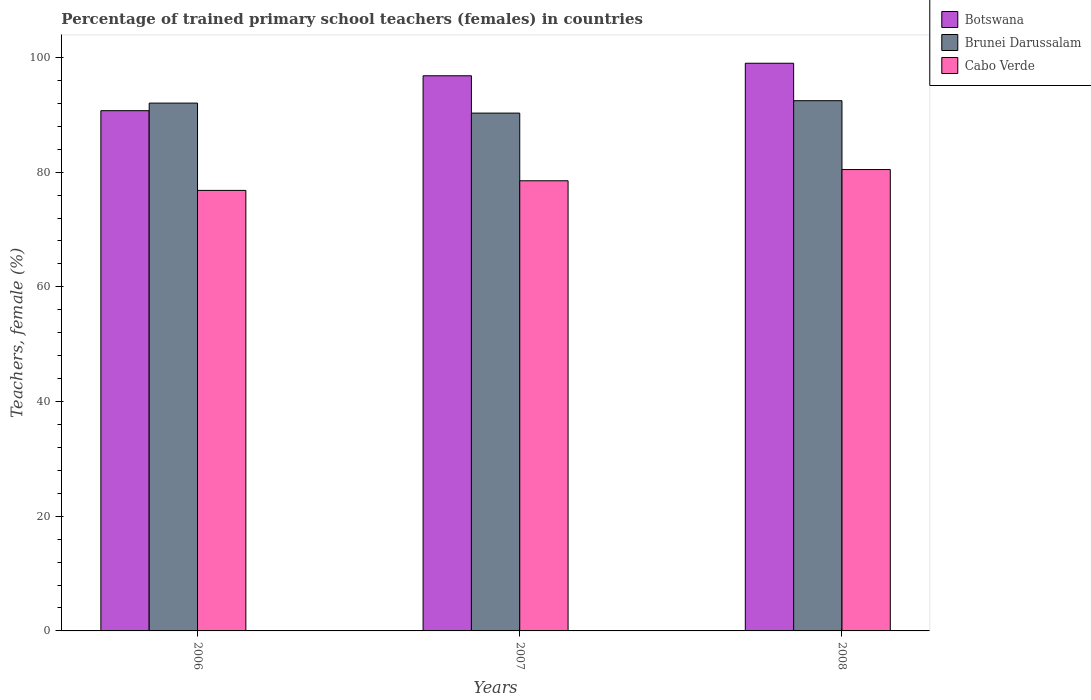Are the number of bars per tick equal to the number of legend labels?
Ensure brevity in your answer.  Yes. Are the number of bars on each tick of the X-axis equal?
Your answer should be very brief. Yes. How many bars are there on the 2nd tick from the left?
Provide a succinct answer. 3. What is the percentage of trained primary school teachers (females) in Botswana in 2008?
Keep it short and to the point. 99. Across all years, what is the maximum percentage of trained primary school teachers (females) in Botswana?
Your response must be concise. 99. Across all years, what is the minimum percentage of trained primary school teachers (females) in Brunei Darussalam?
Offer a terse response. 90.31. What is the total percentage of trained primary school teachers (females) in Botswana in the graph?
Your answer should be very brief. 286.54. What is the difference between the percentage of trained primary school teachers (females) in Brunei Darussalam in 2006 and that in 2007?
Offer a terse response. 1.74. What is the difference between the percentage of trained primary school teachers (females) in Cabo Verde in 2008 and the percentage of trained primary school teachers (females) in Botswana in 2006?
Ensure brevity in your answer.  -10.27. What is the average percentage of trained primary school teachers (females) in Cabo Verde per year?
Give a very brief answer. 78.6. In the year 2007, what is the difference between the percentage of trained primary school teachers (females) in Cabo Verde and percentage of trained primary school teachers (females) in Brunei Darussalam?
Offer a terse response. -11.8. In how many years, is the percentage of trained primary school teachers (females) in Botswana greater than 24 %?
Keep it short and to the point. 3. What is the ratio of the percentage of trained primary school teachers (females) in Cabo Verde in 2006 to that in 2008?
Offer a very short reply. 0.95. Is the percentage of trained primary school teachers (females) in Botswana in 2006 less than that in 2008?
Make the answer very short. Yes. Is the difference between the percentage of trained primary school teachers (females) in Cabo Verde in 2006 and 2008 greater than the difference between the percentage of trained primary school teachers (females) in Brunei Darussalam in 2006 and 2008?
Keep it short and to the point. No. What is the difference between the highest and the second highest percentage of trained primary school teachers (females) in Cabo Verde?
Give a very brief answer. 1.96. What is the difference between the highest and the lowest percentage of trained primary school teachers (females) in Cabo Verde?
Your response must be concise. 3.64. Is the sum of the percentage of trained primary school teachers (females) in Brunei Darussalam in 2006 and 2007 greater than the maximum percentage of trained primary school teachers (females) in Cabo Verde across all years?
Make the answer very short. Yes. What does the 1st bar from the left in 2008 represents?
Give a very brief answer. Botswana. What does the 3rd bar from the right in 2007 represents?
Keep it short and to the point. Botswana. Are all the bars in the graph horizontal?
Your answer should be compact. No. How are the legend labels stacked?
Provide a succinct answer. Vertical. What is the title of the graph?
Your response must be concise. Percentage of trained primary school teachers (females) in countries. What is the label or title of the Y-axis?
Provide a short and direct response. Teachers, female (%). What is the Teachers, female (%) in Botswana in 2006?
Make the answer very short. 90.73. What is the Teachers, female (%) in Brunei Darussalam in 2006?
Your response must be concise. 92.05. What is the Teachers, female (%) in Cabo Verde in 2006?
Your response must be concise. 76.82. What is the Teachers, female (%) of Botswana in 2007?
Offer a terse response. 96.81. What is the Teachers, female (%) in Brunei Darussalam in 2007?
Give a very brief answer. 90.31. What is the Teachers, female (%) in Cabo Verde in 2007?
Your answer should be very brief. 78.5. What is the Teachers, female (%) of Botswana in 2008?
Ensure brevity in your answer.  99. What is the Teachers, female (%) in Brunei Darussalam in 2008?
Your response must be concise. 92.47. What is the Teachers, female (%) in Cabo Verde in 2008?
Make the answer very short. 80.46. Across all years, what is the maximum Teachers, female (%) of Botswana?
Give a very brief answer. 99. Across all years, what is the maximum Teachers, female (%) in Brunei Darussalam?
Your answer should be very brief. 92.47. Across all years, what is the maximum Teachers, female (%) in Cabo Verde?
Your response must be concise. 80.46. Across all years, what is the minimum Teachers, female (%) of Botswana?
Provide a short and direct response. 90.73. Across all years, what is the minimum Teachers, female (%) in Brunei Darussalam?
Give a very brief answer. 90.31. Across all years, what is the minimum Teachers, female (%) of Cabo Verde?
Provide a short and direct response. 76.82. What is the total Teachers, female (%) in Botswana in the graph?
Provide a succinct answer. 286.54. What is the total Teachers, female (%) in Brunei Darussalam in the graph?
Provide a short and direct response. 274.82. What is the total Teachers, female (%) of Cabo Verde in the graph?
Offer a very short reply. 235.79. What is the difference between the Teachers, female (%) in Botswana in 2006 and that in 2007?
Your response must be concise. -6.09. What is the difference between the Teachers, female (%) of Brunei Darussalam in 2006 and that in 2007?
Offer a very short reply. 1.74. What is the difference between the Teachers, female (%) in Cabo Verde in 2006 and that in 2007?
Provide a succinct answer. -1.68. What is the difference between the Teachers, female (%) in Botswana in 2006 and that in 2008?
Keep it short and to the point. -8.27. What is the difference between the Teachers, female (%) in Brunei Darussalam in 2006 and that in 2008?
Offer a very short reply. -0.42. What is the difference between the Teachers, female (%) in Cabo Verde in 2006 and that in 2008?
Offer a very short reply. -3.64. What is the difference between the Teachers, female (%) in Botswana in 2007 and that in 2008?
Offer a very short reply. -2.18. What is the difference between the Teachers, female (%) in Brunei Darussalam in 2007 and that in 2008?
Keep it short and to the point. -2.16. What is the difference between the Teachers, female (%) of Cabo Verde in 2007 and that in 2008?
Offer a very short reply. -1.96. What is the difference between the Teachers, female (%) in Botswana in 2006 and the Teachers, female (%) in Brunei Darussalam in 2007?
Your answer should be very brief. 0.42. What is the difference between the Teachers, female (%) in Botswana in 2006 and the Teachers, female (%) in Cabo Verde in 2007?
Provide a succinct answer. 12.22. What is the difference between the Teachers, female (%) of Brunei Darussalam in 2006 and the Teachers, female (%) of Cabo Verde in 2007?
Keep it short and to the point. 13.55. What is the difference between the Teachers, female (%) in Botswana in 2006 and the Teachers, female (%) in Brunei Darussalam in 2008?
Ensure brevity in your answer.  -1.74. What is the difference between the Teachers, female (%) in Botswana in 2006 and the Teachers, female (%) in Cabo Verde in 2008?
Your answer should be compact. 10.27. What is the difference between the Teachers, female (%) in Brunei Darussalam in 2006 and the Teachers, female (%) in Cabo Verde in 2008?
Provide a short and direct response. 11.59. What is the difference between the Teachers, female (%) of Botswana in 2007 and the Teachers, female (%) of Brunei Darussalam in 2008?
Ensure brevity in your answer.  4.35. What is the difference between the Teachers, female (%) in Botswana in 2007 and the Teachers, female (%) in Cabo Verde in 2008?
Your answer should be very brief. 16.35. What is the difference between the Teachers, female (%) in Brunei Darussalam in 2007 and the Teachers, female (%) in Cabo Verde in 2008?
Your answer should be very brief. 9.85. What is the average Teachers, female (%) of Botswana per year?
Your answer should be compact. 95.51. What is the average Teachers, female (%) in Brunei Darussalam per year?
Provide a succinct answer. 91.61. What is the average Teachers, female (%) in Cabo Verde per year?
Give a very brief answer. 78.6. In the year 2006, what is the difference between the Teachers, female (%) of Botswana and Teachers, female (%) of Brunei Darussalam?
Make the answer very short. -1.32. In the year 2006, what is the difference between the Teachers, female (%) in Botswana and Teachers, female (%) in Cabo Verde?
Offer a terse response. 13.9. In the year 2006, what is the difference between the Teachers, female (%) in Brunei Darussalam and Teachers, female (%) in Cabo Verde?
Offer a very short reply. 15.23. In the year 2007, what is the difference between the Teachers, female (%) of Botswana and Teachers, female (%) of Brunei Darussalam?
Your answer should be compact. 6.51. In the year 2007, what is the difference between the Teachers, female (%) of Botswana and Teachers, female (%) of Cabo Verde?
Provide a succinct answer. 18.31. In the year 2007, what is the difference between the Teachers, female (%) in Brunei Darussalam and Teachers, female (%) in Cabo Verde?
Your answer should be compact. 11.8. In the year 2008, what is the difference between the Teachers, female (%) of Botswana and Teachers, female (%) of Brunei Darussalam?
Your answer should be very brief. 6.53. In the year 2008, what is the difference between the Teachers, female (%) in Botswana and Teachers, female (%) in Cabo Verde?
Your answer should be compact. 18.54. In the year 2008, what is the difference between the Teachers, female (%) in Brunei Darussalam and Teachers, female (%) in Cabo Verde?
Provide a succinct answer. 12.01. What is the ratio of the Teachers, female (%) of Botswana in 2006 to that in 2007?
Provide a short and direct response. 0.94. What is the ratio of the Teachers, female (%) in Brunei Darussalam in 2006 to that in 2007?
Keep it short and to the point. 1.02. What is the ratio of the Teachers, female (%) in Cabo Verde in 2006 to that in 2007?
Make the answer very short. 0.98. What is the ratio of the Teachers, female (%) in Botswana in 2006 to that in 2008?
Provide a short and direct response. 0.92. What is the ratio of the Teachers, female (%) in Brunei Darussalam in 2006 to that in 2008?
Your response must be concise. 1. What is the ratio of the Teachers, female (%) in Cabo Verde in 2006 to that in 2008?
Ensure brevity in your answer.  0.95. What is the ratio of the Teachers, female (%) in Brunei Darussalam in 2007 to that in 2008?
Offer a very short reply. 0.98. What is the ratio of the Teachers, female (%) of Cabo Verde in 2007 to that in 2008?
Keep it short and to the point. 0.98. What is the difference between the highest and the second highest Teachers, female (%) in Botswana?
Offer a terse response. 2.18. What is the difference between the highest and the second highest Teachers, female (%) of Brunei Darussalam?
Your answer should be very brief. 0.42. What is the difference between the highest and the second highest Teachers, female (%) in Cabo Verde?
Offer a terse response. 1.96. What is the difference between the highest and the lowest Teachers, female (%) of Botswana?
Give a very brief answer. 8.27. What is the difference between the highest and the lowest Teachers, female (%) of Brunei Darussalam?
Provide a short and direct response. 2.16. What is the difference between the highest and the lowest Teachers, female (%) of Cabo Verde?
Your answer should be very brief. 3.64. 